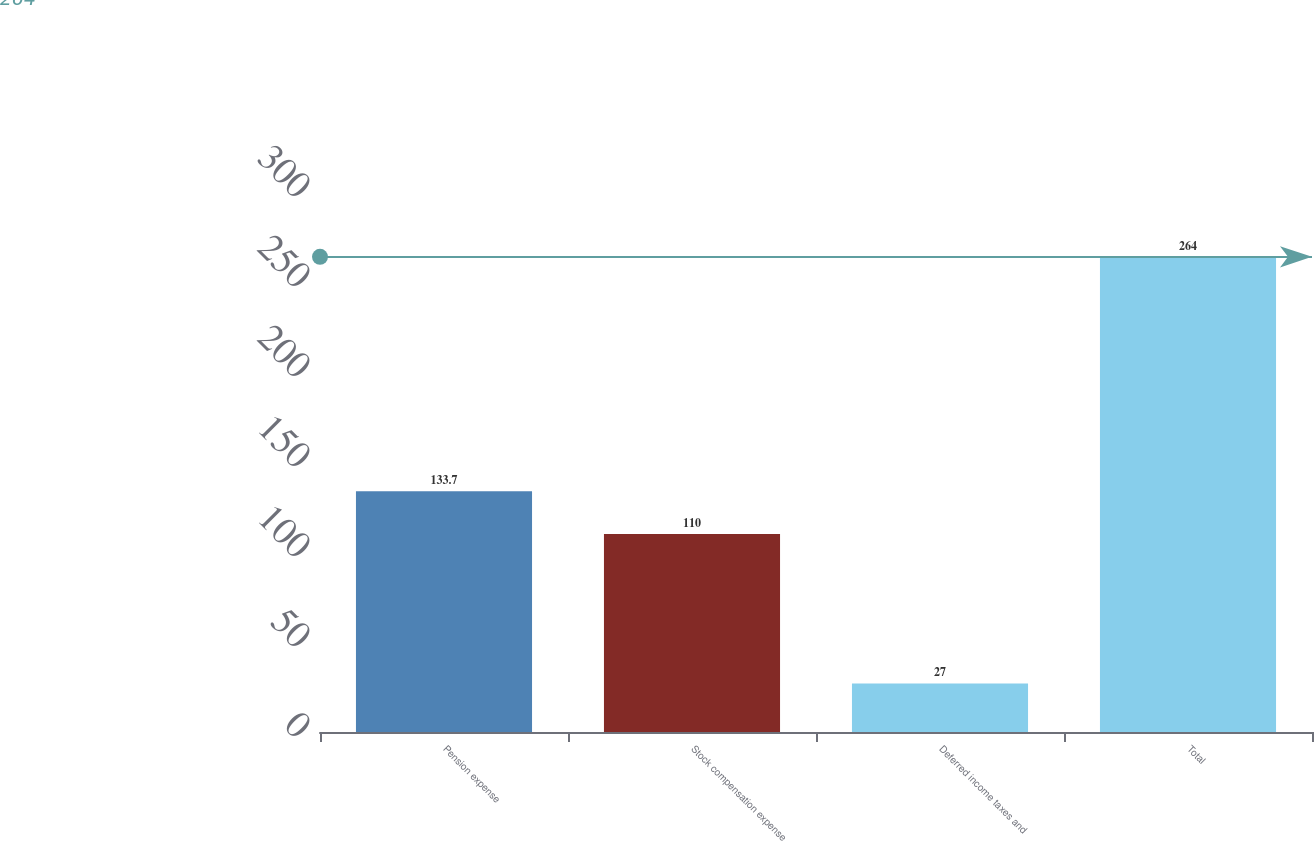Convert chart. <chart><loc_0><loc_0><loc_500><loc_500><bar_chart><fcel>Pension expense<fcel>Stock compensation expense<fcel>Deferred income taxes and<fcel>Total<nl><fcel>133.7<fcel>110<fcel>27<fcel>264<nl></chart> 